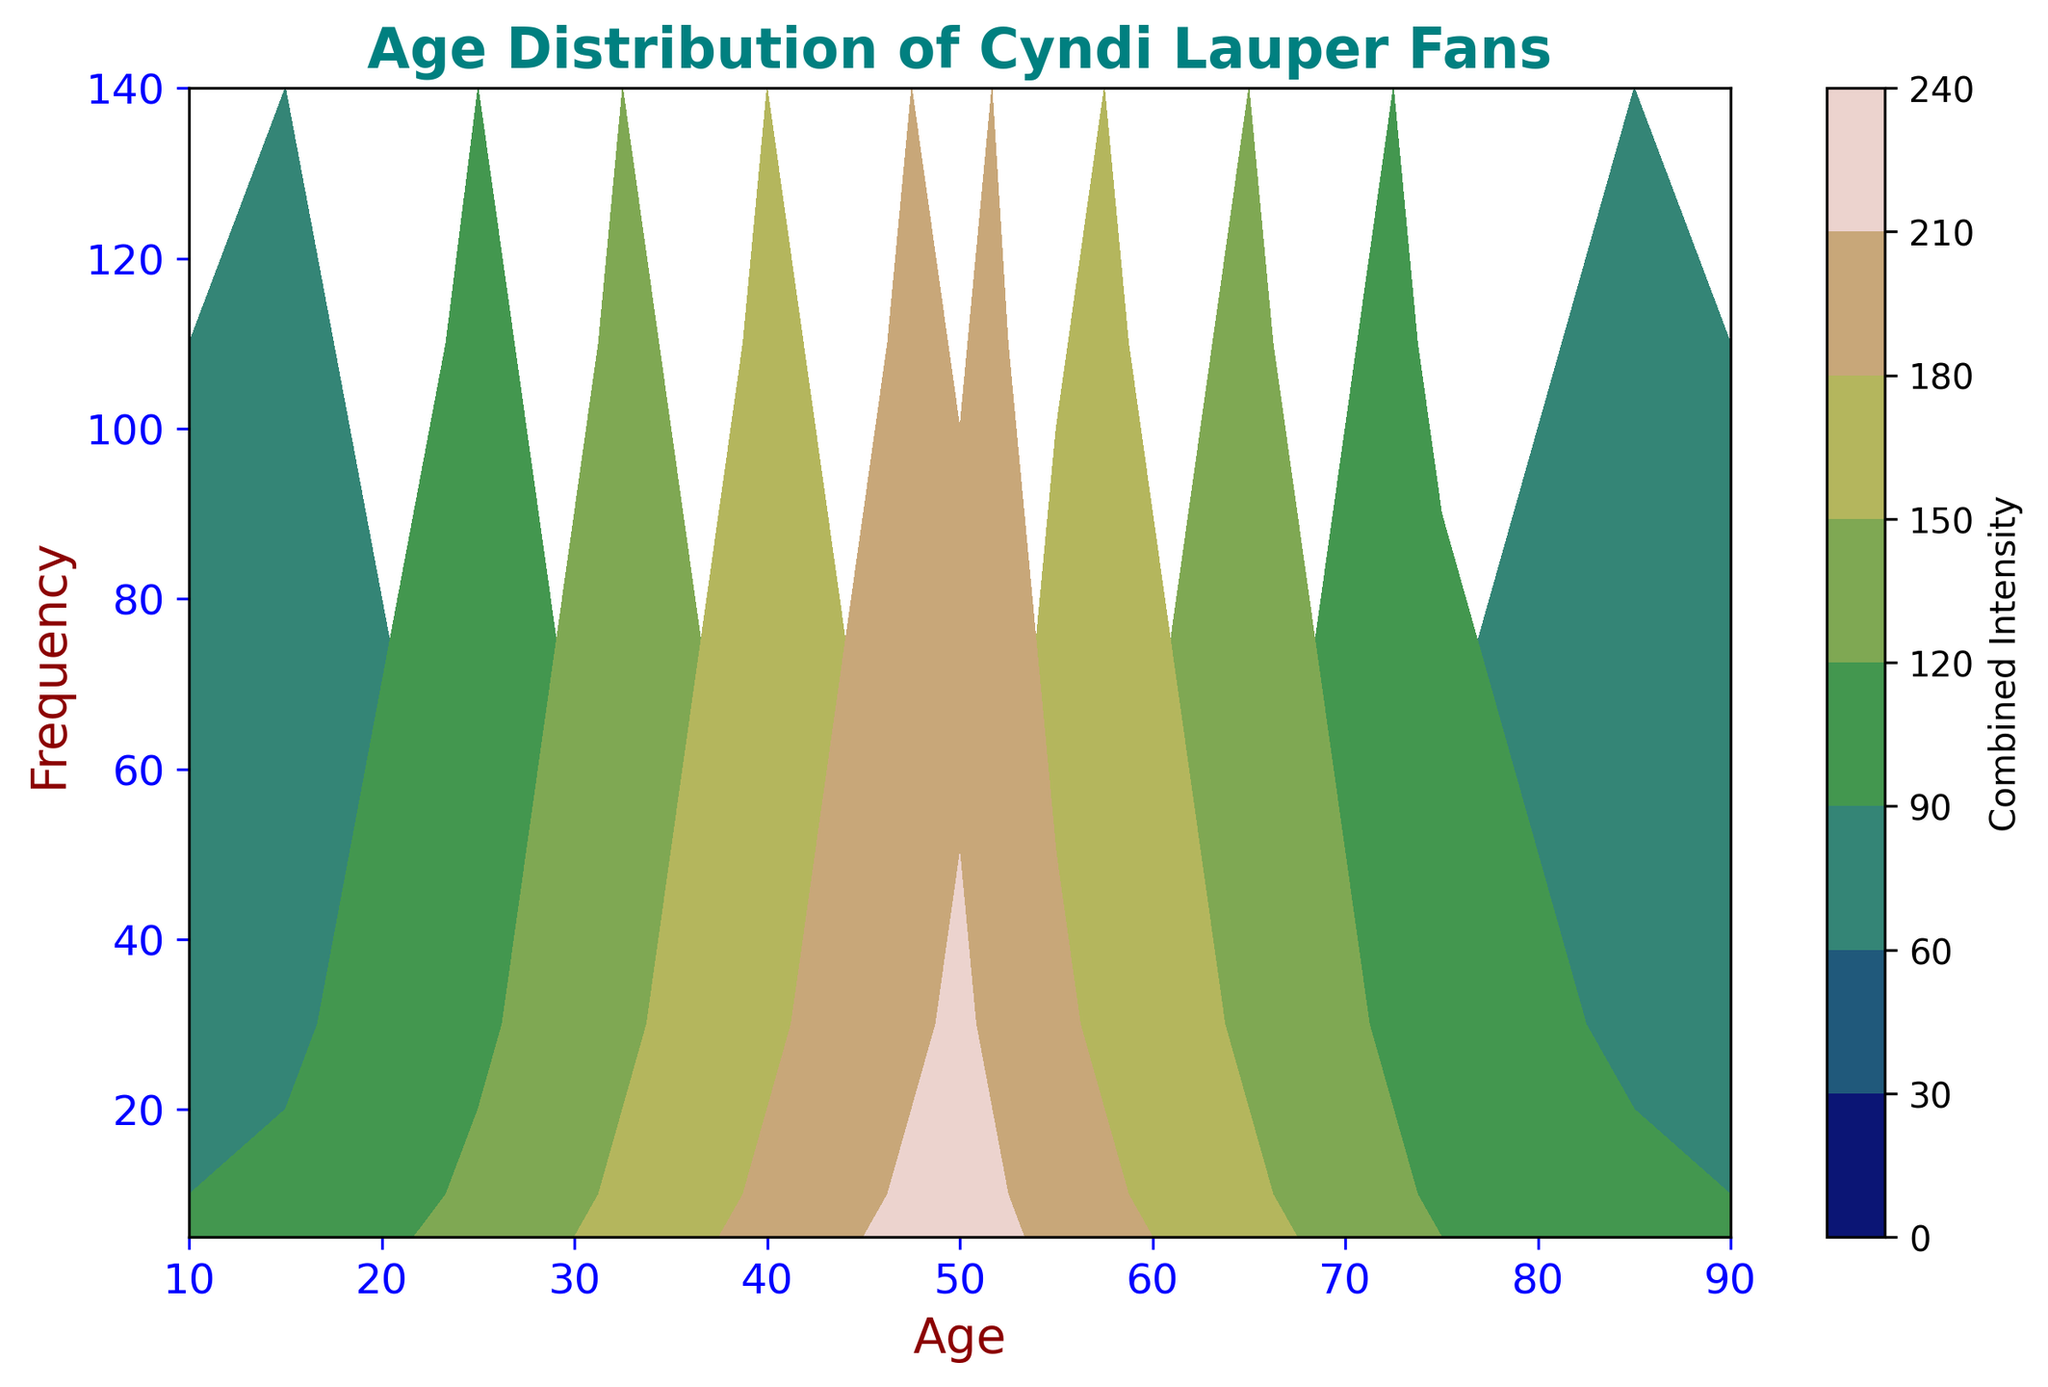What is the age group that shows the highest frequency? Examining the plot, we see the highest point on the y-axis corresponds to the age group of 50, indicating that 50-year-olds attend Cyndi Lauper concerts the most.
Answer: 50 What age group shows a frequency of 90? Looking at the contour plot, the frequency value of 90 intersects at age 60, suggesting this age group attends concerts with a frequency of 90.
Answer: 60 What is the combined intensity at the contour where both age and frequency intersect at 140? To find this, we see the age 50 combination intersecting with a frequency of 140. The combined intensity 'Z' is determined by adding age 50 and frequency 140, yielding 190.
Answer: 190 What is the combined intensity when age is 40 and frequency is 80? Using the contour formula, which adds age and frequency values, for age 40 and frequency 80, the combined intensity will be 40 + 80 = 120.
Answer: 120 At what age range does the attendance frequency start declining after peaking? By observing the plot, after peaking at the age 50 with the highest frequency of 140, any frequencies beyond this age start showing lower values starting from age 55 onwards.
Answer: 55 What is the difference in combined intensity between the age groups 60 and 30? The combined intensity for age 60 is 60 + 90 = 150, whereas for age 30 it is 30 + 60 = 90. The difference is 150 - 90 = 60.
Answer: 60 Which age groups have a combined intensity of 120? To achieve a combined intensity of 120, age and frequency pairs need to add up to 120. As seen, 40 (age) + 80 (frequency) = 120, and 50 (age) + 70 (frequency) = 120. Both age 40 and 50 meet this criteria.
Answer: 40 and 50 How does the combined intensity change from age 45 to age 55? At age 45 combined intensity with frequency 120 gives 45 + 120 = 165. At age 55 combined intensity with frequency 110 gives 55 + 110 = 165. Thus, the combined intensity remains the same.
Answer: Remains the same Which age group displays a significantly steep increase in frequency? Referring to the plot, there is a prominent steep increase in frequency from age 30 (60) to age 50 (140), showing a sharp rise in that age group.
Answer: 30 to 50 How does the color vary for age ranges from 10 to 80? Visual inspection of color patterns reveals a gradient, becoming darker as age increases, peaking around 50, then gradually lightening from 55 to 80, indicating frequency and combined intensity variations.
Answer: Gradually darkening to 50 then lightening 